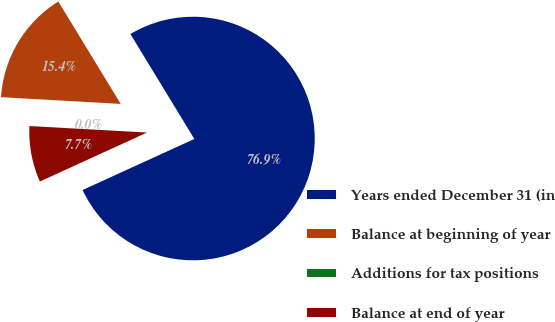Convert chart to OTSL. <chart><loc_0><loc_0><loc_500><loc_500><pie_chart><fcel>Years ended December 31 (in<fcel>Balance at beginning of year<fcel>Additions for tax positions<fcel>Balance at end of year<nl><fcel>76.89%<fcel>15.39%<fcel>0.02%<fcel>7.7%<nl></chart> 